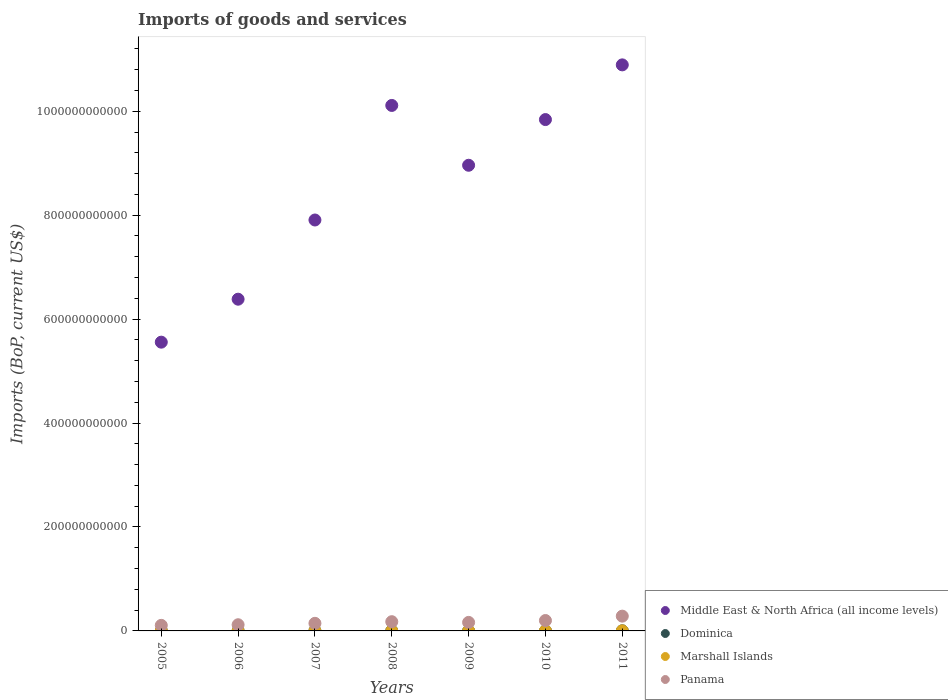How many different coloured dotlines are there?
Provide a succinct answer. 4. Is the number of dotlines equal to the number of legend labels?
Offer a terse response. Yes. What is the amount spent on imports in Dominica in 2010?
Provide a succinct answer. 2.65e+08. Across all years, what is the maximum amount spent on imports in Marshall Islands?
Your answer should be very brief. 1.75e+08. Across all years, what is the minimum amount spent on imports in Middle East & North Africa (all income levels)?
Keep it short and to the point. 5.56e+11. In which year was the amount spent on imports in Marshall Islands minimum?
Offer a very short reply. 2006. What is the total amount spent on imports in Dominica in the graph?
Your response must be concise. 1.71e+09. What is the difference between the amount spent on imports in Marshall Islands in 2005 and that in 2011?
Provide a succinct answer. -4.01e+07. What is the difference between the amount spent on imports in Middle East & North Africa (all income levels) in 2008 and the amount spent on imports in Dominica in 2009?
Offer a terse response. 1.01e+12. What is the average amount spent on imports in Dominica per year?
Keep it short and to the point. 2.45e+08. In the year 2005, what is the difference between the amount spent on imports in Middle East & North Africa (all income levels) and amount spent on imports in Marshall Islands?
Keep it short and to the point. 5.56e+11. In how many years, is the amount spent on imports in Panama greater than 160000000000 US$?
Offer a terse response. 0. What is the ratio of the amount spent on imports in Dominica in 2009 to that in 2010?
Provide a short and direct response. 1. What is the difference between the highest and the second highest amount spent on imports in Marshall Islands?
Provide a succinct answer. 1.13e+07. What is the difference between the highest and the lowest amount spent on imports in Dominica?
Ensure brevity in your answer.  9.12e+07. In how many years, is the amount spent on imports in Panama greater than the average amount spent on imports in Panama taken over all years?
Offer a very short reply. 3. Is the sum of the amount spent on imports in Marshall Islands in 2010 and 2011 greater than the maximum amount spent on imports in Panama across all years?
Your answer should be compact. No. Is it the case that in every year, the sum of the amount spent on imports in Marshall Islands and amount spent on imports in Dominica  is greater than the sum of amount spent on imports in Middle East & North Africa (all income levels) and amount spent on imports in Panama?
Your answer should be very brief. Yes. Is it the case that in every year, the sum of the amount spent on imports in Marshall Islands and amount spent on imports in Panama  is greater than the amount spent on imports in Middle East & North Africa (all income levels)?
Provide a succinct answer. No. Does the amount spent on imports in Panama monotonically increase over the years?
Your answer should be compact. No. Is the amount spent on imports in Dominica strictly greater than the amount spent on imports in Panama over the years?
Your response must be concise. No. How many years are there in the graph?
Keep it short and to the point. 7. What is the difference between two consecutive major ticks on the Y-axis?
Offer a terse response. 2.00e+11. How many legend labels are there?
Your response must be concise. 4. What is the title of the graph?
Your response must be concise. Imports of goods and services. What is the label or title of the Y-axis?
Keep it short and to the point. Imports (BoP, current US$). What is the Imports (BoP, current US$) of Middle East & North Africa (all income levels) in 2005?
Your answer should be very brief. 5.56e+11. What is the Imports (BoP, current US$) in Dominica in 2005?
Give a very brief answer. 1.96e+08. What is the Imports (BoP, current US$) of Marshall Islands in 2005?
Make the answer very short. 1.35e+08. What is the Imports (BoP, current US$) of Panama in 2005?
Ensure brevity in your answer.  1.07e+1. What is the Imports (BoP, current US$) of Middle East & North Africa (all income levels) in 2006?
Ensure brevity in your answer.  6.38e+11. What is the Imports (BoP, current US$) of Dominica in 2006?
Provide a short and direct response. 1.99e+08. What is the Imports (BoP, current US$) of Marshall Islands in 2006?
Your answer should be compact. 1.29e+08. What is the Imports (BoP, current US$) in Panama in 2006?
Keep it short and to the point. 1.19e+1. What is the Imports (BoP, current US$) in Middle East & North Africa (all income levels) in 2007?
Provide a succinct answer. 7.91e+11. What is the Imports (BoP, current US$) in Dominica in 2007?
Give a very brief answer. 2.36e+08. What is the Imports (BoP, current US$) of Marshall Islands in 2007?
Offer a terse response. 1.41e+08. What is the Imports (BoP, current US$) of Panama in 2007?
Provide a short and direct response. 1.46e+1. What is the Imports (BoP, current US$) of Middle East & North Africa (all income levels) in 2008?
Offer a terse response. 1.01e+12. What is the Imports (BoP, current US$) in Dominica in 2008?
Provide a short and direct response. 2.87e+08. What is the Imports (BoP, current US$) in Marshall Islands in 2008?
Ensure brevity in your answer.  1.39e+08. What is the Imports (BoP, current US$) of Panama in 2008?
Make the answer very short. 1.78e+1. What is the Imports (BoP, current US$) of Middle East & North Africa (all income levels) in 2009?
Ensure brevity in your answer.  8.96e+11. What is the Imports (BoP, current US$) of Dominica in 2009?
Provide a short and direct response. 2.64e+08. What is the Imports (BoP, current US$) in Marshall Islands in 2009?
Your response must be concise. 1.58e+08. What is the Imports (BoP, current US$) in Panama in 2009?
Make the answer very short. 1.64e+1. What is the Imports (BoP, current US$) in Middle East & North Africa (all income levels) in 2010?
Keep it short and to the point. 9.84e+11. What is the Imports (BoP, current US$) in Dominica in 2010?
Keep it short and to the point. 2.65e+08. What is the Imports (BoP, current US$) of Marshall Islands in 2010?
Your response must be concise. 1.64e+08. What is the Imports (BoP, current US$) of Panama in 2010?
Ensure brevity in your answer.  2.00e+1. What is the Imports (BoP, current US$) in Middle East & North Africa (all income levels) in 2011?
Your answer should be very brief. 1.09e+12. What is the Imports (BoP, current US$) in Dominica in 2011?
Offer a terse response. 2.65e+08. What is the Imports (BoP, current US$) in Marshall Islands in 2011?
Provide a succinct answer. 1.75e+08. What is the Imports (BoP, current US$) of Panama in 2011?
Provide a succinct answer. 2.84e+1. Across all years, what is the maximum Imports (BoP, current US$) in Middle East & North Africa (all income levels)?
Your answer should be very brief. 1.09e+12. Across all years, what is the maximum Imports (BoP, current US$) of Dominica?
Offer a very short reply. 2.87e+08. Across all years, what is the maximum Imports (BoP, current US$) in Marshall Islands?
Provide a succinct answer. 1.75e+08. Across all years, what is the maximum Imports (BoP, current US$) in Panama?
Keep it short and to the point. 2.84e+1. Across all years, what is the minimum Imports (BoP, current US$) of Middle East & North Africa (all income levels)?
Your response must be concise. 5.56e+11. Across all years, what is the minimum Imports (BoP, current US$) of Dominica?
Offer a terse response. 1.96e+08. Across all years, what is the minimum Imports (BoP, current US$) of Marshall Islands?
Your answer should be very brief. 1.29e+08. Across all years, what is the minimum Imports (BoP, current US$) in Panama?
Ensure brevity in your answer.  1.07e+1. What is the total Imports (BoP, current US$) in Middle East & North Africa (all income levels) in the graph?
Provide a succinct answer. 5.96e+12. What is the total Imports (BoP, current US$) in Dominica in the graph?
Offer a terse response. 1.71e+09. What is the total Imports (BoP, current US$) of Marshall Islands in the graph?
Offer a terse response. 1.04e+09. What is the total Imports (BoP, current US$) in Panama in the graph?
Make the answer very short. 1.20e+11. What is the difference between the Imports (BoP, current US$) of Middle East & North Africa (all income levels) in 2005 and that in 2006?
Keep it short and to the point. -8.27e+1. What is the difference between the Imports (BoP, current US$) of Dominica in 2005 and that in 2006?
Ensure brevity in your answer.  -2.73e+06. What is the difference between the Imports (BoP, current US$) of Marshall Islands in 2005 and that in 2006?
Your answer should be very brief. 5.65e+06. What is the difference between the Imports (BoP, current US$) of Panama in 2005 and that in 2006?
Offer a very short reply. -1.18e+09. What is the difference between the Imports (BoP, current US$) of Middle East & North Africa (all income levels) in 2005 and that in 2007?
Provide a short and direct response. -2.35e+11. What is the difference between the Imports (BoP, current US$) in Dominica in 2005 and that in 2007?
Keep it short and to the point. -4.02e+07. What is the difference between the Imports (BoP, current US$) of Marshall Islands in 2005 and that in 2007?
Your answer should be very brief. -5.87e+06. What is the difference between the Imports (BoP, current US$) of Panama in 2005 and that in 2007?
Provide a short and direct response. -3.91e+09. What is the difference between the Imports (BoP, current US$) of Middle East & North Africa (all income levels) in 2005 and that in 2008?
Offer a very short reply. -4.55e+11. What is the difference between the Imports (BoP, current US$) of Dominica in 2005 and that in 2008?
Provide a succinct answer. -9.12e+07. What is the difference between the Imports (BoP, current US$) of Marshall Islands in 2005 and that in 2008?
Your answer should be compact. -4.35e+06. What is the difference between the Imports (BoP, current US$) of Panama in 2005 and that in 2008?
Give a very brief answer. -7.06e+09. What is the difference between the Imports (BoP, current US$) in Middle East & North Africa (all income levels) in 2005 and that in 2009?
Your response must be concise. -3.40e+11. What is the difference between the Imports (BoP, current US$) in Dominica in 2005 and that in 2009?
Your answer should be compact. -6.83e+07. What is the difference between the Imports (BoP, current US$) of Marshall Islands in 2005 and that in 2009?
Offer a very short reply. -2.31e+07. What is the difference between the Imports (BoP, current US$) in Panama in 2005 and that in 2009?
Offer a very short reply. -5.71e+09. What is the difference between the Imports (BoP, current US$) of Middle East & North Africa (all income levels) in 2005 and that in 2010?
Ensure brevity in your answer.  -4.28e+11. What is the difference between the Imports (BoP, current US$) in Dominica in 2005 and that in 2010?
Your answer should be compact. -6.84e+07. What is the difference between the Imports (BoP, current US$) of Marshall Islands in 2005 and that in 2010?
Provide a succinct answer. -2.88e+07. What is the difference between the Imports (BoP, current US$) of Panama in 2005 and that in 2010?
Your answer should be compact. -9.30e+09. What is the difference between the Imports (BoP, current US$) of Middle East & North Africa (all income levels) in 2005 and that in 2011?
Provide a short and direct response. -5.34e+11. What is the difference between the Imports (BoP, current US$) in Dominica in 2005 and that in 2011?
Keep it short and to the point. -6.87e+07. What is the difference between the Imports (BoP, current US$) of Marshall Islands in 2005 and that in 2011?
Offer a terse response. -4.01e+07. What is the difference between the Imports (BoP, current US$) in Panama in 2005 and that in 2011?
Your response must be concise. -1.77e+1. What is the difference between the Imports (BoP, current US$) of Middle East & North Africa (all income levels) in 2006 and that in 2007?
Ensure brevity in your answer.  -1.52e+11. What is the difference between the Imports (BoP, current US$) in Dominica in 2006 and that in 2007?
Provide a short and direct response. -3.75e+07. What is the difference between the Imports (BoP, current US$) of Marshall Islands in 2006 and that in 2007?
Make the answer very short. -1.15e+07. What is the difference between the Imports (BoP, current US$) of Panama in 2006 and that in 2007?
Your response must be concise. -2.73e+09. What is the difference between the Imports (BoP, current US$) of Middle East & North Africa (all income levels) in 2006 and that in 2008?
Provide a succinct answer. -3.73e+11. What is the difference between the Imports (BoP, current US$) in Dominica in 2006 and that in 2008?
Keep it short and to the point. -8.85e+07. What is the difference between the Imports (BoP, current US$) of Marshall Islands in 2006 and that in 2008?
Offer a very short reply. -9.99e+06. What is the difference between the Imports (BoP, current US$) in Panama in 2006 and that in 2008?
Keep it short and to the point. -5.87e+09. What is the difference between the Imports (BoP, current US$) in Middle East & North Africa (all income levels) in 2006 and that in 2009?
Make the answer very short. -2.58e+11. What is the difference between the Imports (BoP, current US$) of Dominica in 2006 and that in 2009?
Keep it short and to the point. -6.56e+07. What is the difference between the Imports (BoP, current US$) in Marshall Islands in 2006 and that in 2009?
Offer a very short reply. -2.88e+07. What is the difference between the Imports (BoP, current US$) of Panama in 2006 and that in 2009?
Keep it short and to the point. -4.52e+09. What is the difference between the Imports (BoP, current US$) in Middle East & North Africa (all income levels) in 2006 and that in 2010?
Your answer should be compact. -3.46e+11. What is the difference between the Imports (BoP, current US$) in Dominica in 2006 and that in 2010?
Offer a very short reply. -6.57e+07. What is the difference between the Imports (BoP, current US$) of Marshall Islands in 2006 and that in 2010?
Ensure brevity in your answer.  -3.45e+07. What is the difference between the Imports (BoP, current US$) in Panama in 2006 and that in 2010?
Keep it short and to the point. -8.12e+09. What is the difference between the Imports (BoP, current US$) in Middle East & North Africa (all income levels) in 2006 and that in 2011?
Keep it short and to the point. -4.51e+11. What is the difference between the Imports (BoP, current US$) in Dominica in 2006 and that in 2011?
Offer a terse response. -6.60e+07. What is the difference between the Imports (BoP, current US$) in Marshall Islands in 2006 and that in 2011?
Provide a short and direct response. -4.58e+07. What is the difference between the Imports (BoP, current US$) of Panama in 2006 and that in 2011?
Give a very brief answer. -1.66e+1. What is the difference between the Imports (BoP, current US$) in Middle East & North Africa (all income levels) in 2007 and that in 2008?
Give a very brief answer. -2.20e+11. What is the difference between the Imports (BoP, current US$) of Dominica in 2007 and that in 2008?
Keep it short and to the point. -5.10e+07. What is the difference between the Imports (BoP, current US$) in Marshall Islands in 2007 and that in 2008?
Offer a terse response. 1.53e+06. What is the difference between the Imports (BoP, current US$) in Panama in 2007 and that in 2008?
Give a very brief answer. -3.14e+09. What is the difference between the Imports (BoP, current US$) in Middle East & North Africa (all income levels) in 2007 and that in 2009?
Ensure brevity in your answer.  -1.05e+11. What is the difference between the Imports (BoP, current US$) in Dominica in 2007 and that in 2009?
Provide a short and direct response. -2.81e+07. What is the difference between the Imports (BoP, current US$) of Marshall Islands in 2007 and that in 2009?
Your response must be concise. -1.72e+07. What is the difference between the Imports (BoP, current US$) in Panama in 2007 and that in 2009?
Offer a very short reply. -1.79e+09. What is the difference between the Imports (BoP, current US$) in Middle East & North Africa (all income levels) in 2007 and that in 2010?
Provide a succinct answer. -1.93e+11. What is the difference between the Imports (BoP, current US$) of Dominica in 2007 and that in 2010?
Ensure brevity in your answer.  -2.82e+07. What is the difference between the Imports (BoP, current US$) in Marshall Islands in 2007 and that in 2010?
Offer a very short reply. -2.30e+07. What is the difference between the Imports (BoP, current US$) in Panama in 2007 and that in 2010?
Make the answer very short. -5.39e+09. What is the difference between the Imports (BoP, current US$) of Middle East & North Africa (all income levels) in 2007 and that in 2011?
Keep it short and to the point. -2.98e+11. What is the difference between the Imports (BoP, current US$) in Dominica in 2007 and that in 2011?
Provide a short and direct response. -2.85e+07. What is the difference between the Imports (BoP, current US$) of Marshall Islands in 2007 and that in 2011?
Keep it short and to the point. -3.42e+07. What is the difference between the Imports (BoP, current US$) of Panama in 2007 and that in 2011?
Offer a terse response. -1.38e+1. What is the difference between the Imports (BoP, current US$) of Middle East & North Africa (all income levels) in 2008 and that in 2009?
Keep it short and to the point. 1.15e+11. What is the difference between the Imports (BoP, current US$) in Dominica in 2008 and that in 2009?
Provide a short and direct response. 2.29e+07. What is the difference between the Imports (BoP, current US$) of Marshall Islands in 2008 and that in 2009?
Offer a terse response. -1.88e+07. What is the difference between the Imports (BoP, current US$) in Panama in 2008 and that in 2009?
Ensure brevity in your answer.  1.35e+09. What is the difference between the Imports (BoP, current US$) in Middle East & North Africa (all income levels) in 2008 and that in 2010?
Keep it short and to the point. 2.72e+1. What is the difference between the Imports (BoP, current US$) in Dominica in 2008 and that in 2010?
Ensure brevity in your answer.  2.28e+07. What is the difference between the Imports (BoP, current US$) of Marshall Islands in 2008 and that in 2010?
Offer a very short reply. -2.45e+07. What is the difference between the Imports (BoP, current US$) in Panama in 2008 and that in 2010?
Your response must be concise. -2.24e+09. What is the difference between the Imports (BoP, current US$) of Middle East & North Africa (all income levels) in 2008 and that in 2011?
Your response must be concise. -7.81e+1. What is the difference between the Imports (BoP, current US$) in Dominica in 2008 and that in 2011?
Your answer should be compact. 2.25e+07. What is the difference between the Imports (BoP, current US$) of Marshall Islands in 2008 and that in 2011?
Offer a terse response. -3.58e+07. What is the difference between the Imports (BoP, current US$) of Panama in 2008 and that in 2011?
Your answer should be very brief. -1.07e+1. What is the difference between the Imports (BoP, current US$) of Middle East & North Africa (all income levels) in 2009 and that in 2010?
Keep it short and to the point. -8.79e+1. What is the difference between the Imports (BoP, current US$) of Dominica in 2009 and that in 2010?
Ensure brevity in your answer.  -5.28e+04. What is the difference between the Imports (BoP, current US$) in Marshall Islands in 2009 and that in 2010?
Keep it short and to the point. -5.73e+06. What is the difference between the Imports (BoP, current US$) of Panama in 2009 and that in 2010?
Offer a terse response. -3.59e+09. What is the difference between the Imports (BoP, current US$) of Middle East & North Africa (all income levels) in 2009 and that in 2011?
Your response must be concise. -1.93e+11. What is the difference between the Imports (BoP, current US$) in Dominica in 2009 and that in 2011?
Give a very brief answer. -3.41e+05. What is the difference between the Imports (BoP, current US$) in Marshall Islands in 2009 and that in 2011?
Give a very brief answer. -1.70e+07. What is the difference between the Imports (BoP, current US$) in Panama in 2009 and that in 2011?
Offer a terse response. -1.20e+1. What is the difference between the Imports (BoP, current US$) of Middle East & North Africa (all income levels) in 2010 and that in 2011?
Give a very brief answer. -1.05e+11. What is the difference between the Imports (BoP, current US$) of Dominica in 2010 and that in 2011?
Offer a terse response. -2.88e+05. What is the difference between the Imports (BoP, current US$) in Marshall Islands in 2010 and that in 2011?
Offer a very short reply. -1.13e+07. What is the difference between the Imports (BoP, current US$) of Panama in 2010 and that in 2011?
Offer a very short reply. -8.44e+09. What is the difference between the Imports (BoP, current US$) of Middle East & North Africa (all income levels) in 2005 and the Imports (BoP, current US$) of Dominica in 2006?
Make the answer very short. 5.55e+11. What is the difference between the Imports (BoP, current US$) in Middle East & North Africa (all income levels) in 2005 and the Imports (BoP, current US$) in Marshall Islands in 2006?
Your response must be concise. 5.56e+11. What is the difference between the Imports (BoP, current US$) in Middle East & North Africa (all income levels) in 2005 and the Imports (BoP, current US$) in Panama in 2006?
Provide a succinct answer. 5.44e+11. What is the difference between the Imports (BoP, current US$) in Dominica in 2005 and the Imports (BoP, current US$) in Marshall Islands in 2006?
Offer a very short reply. 6.69e+07. What is the difference between the Imports (BoP, current US$) of Dominica in 2005 and the Imports (BoP, current US$) of Panama in 2006?
Offer a very short reply. -1.17e+1. What is the difference between the Imports (BoP, current US$) of Marshall Islands in 2005 and the Imports (BoP, current US$) of Panama in 2006?
Your answer should be compact. -1.18e+1. What is the difference between the Imports (BoP, current US$) of Middle East & North Africa (all income levels) in 2005 and the Imports (BoP, current US$) of Dominica in 2007?
Provide a short and direct response. 5.55e+11. What is the difference between the Imports (BoP, current US$) of Middle East & North Africa (all income levels) in 2005 and the Imports (BoP, current US$) of Marshall Islands in 2007?
Your answer should be compact. 5.56e+11. What is the difference between the Imports (BoP, current US$) of Middle East & North Africa (all income levels) in 2005 and the Imports (BoP, current US$) of Panama in 2007?
Your answer should be compact. 5.41e+11. What is the difference between the Imports (BoP, current US$) of Dominica in 2005 and the Imports (BoP, current US$) of Marshall Islands in 2007?
Ensure brevity in your answer.  5.54e+07. What is the difference between the Imports (BoP, current US$) of Dominica in 2005 and the Imports (BoP, current US$) of Panama in 2007?
Provide a succinct answer. -1.44e+1. What is the difference between the Imports (BoP, current US$) in Marshall Islands in 2005 and the Imports (BoP, current US$) in Panama in 2007?
Offer a very short reply. -1.45e+1. What is the difference between the Imports (BoP, current US$) in Middle East & North Africa (all income levels) in 2005 and the Imports (BoP, current US$) in Dominica in 2008?
Offer a terse response. 5.55e+11. What is the difference between the Imports (BoP, current US$) in Middle East & North Africa (all income levels) in 2005 and the Imports (BoP, current US$) in Marshall Islands in 2008?
Your answer should be compact. 5.56e+11. What is the difference between the Imports (BoP, current US$) of Middle East & North Africa (all income levels) in 2005 and the Imports (BoP, current US$) of Panama in 2008?
Provide a short and direct response. 5.38e+11. What is the difference between the Imports (BoP, current US$) of Dominica in 2005 and the Imports (BoP, current US$) of Marshall Islands in 2008?
Provide a succinct answer. 5.70e+07. What is the difference between the Imports (BoP, current US$) of Dominica in 2005 and the Imports (BoP, current US$) of Panama in 2008?
Provide a short and direct response. -1.76e+1. What is the difference between the Imports (BoP, current US$) of Marshall Islands in 2005 and the Imports (BoP, current US$) of Panama in 2008?
Provide a short and direct response. -1.76e+1. What is the difference between the Imports (BoP, current US$) of Middle East & North Africa (all income levels) in 2005 and the Imports (BoP, current US$) of Dominica in 2009?
Ensure brevity in your answer.  5.55e+11. What is the difference between the Imports (BoP, current US$) in Middle East & North Africa (all income levels) in 2005 and the Imports (BoP, current US$) in Marshall Islands in 2009?
Your response must be concise. 5.55e+11. What is the difference between the Imports (BoP, current US$) of Middle East & North Africa (all income levels) in 2005 and the Imports (BoP, current US$) of Panama in 2009?
Your answer should be very brief. 5.39e+11. What is the difference between the Imports (BoP, current US$) of Dominica in 2005 and the Imports (BoP, current US$) of Marshall Islands in 2009?
Make the answer very short. 3.82e+07. What is the difference between the Imports (BoP, current US$) of Dominica in 2005 and the Imports (BoP, current US$) of Panama in 2009?
Your response must be concise. -1.62e+1. What is the difference between the Imports (BoP, current US$) of Marshall Islands in 2005 and the Imports (BoP, current US$) of Panama in 2009?
Provide a succinct answer. -1.63e+1. What is the difference between the Imports (BoP, current US$) of Middle East & North Africa (all income levels) in 2005 and the Imports (BoP, current US$) of Dominica in 2010?
Your answer should be compact. 5.55e+11. What is the difference between the Imports (BoP, current US$) of Middle East & North Africa (all income levels) in 2005 and the Imports (BoP, current US$) of Marshall Islands in 2010?
Make the answer very short. 5.55e+11. What is the difference between the Imports (BoP, current US$) of Middle East & North Africa (all income levels) in 2005 and the Imports (BoP, current US$) of Panama in 2010?
Your answer should be very brief. 5.36e+11. What is the difference between the Imports (BoP, current US$) of Dominica in 2005 and the Imports (BoP, current US$) of Marshall Islands in 2010?
Give a very brief answer. 3.25e+07. What is the difference between the Imports (BoP, current US$) of Dominica in 2005 and the Imports (BoP, current US$) of Panama in 2010?
Provide a short and direct response. -1.98e+1. What is the difference between the Imports (BoP, current US$) of Marshall Islands in 2005 and the Imports (BoP, current US$) of Panama in 2010?
Provide a succinct answer. -1.99e+1. What is the difference between the Imports (BoP, current US$) in Middle East & North Africa (all income levels) in 2005 and the Imports (BoP, current US$) in Dominica in 2011?
Provide a succinct answer. 5.55e+11. What is the difference between the Imports (BoP, current US$) of Middle East & North Africa (all income levels) in 2005 and the Imports (BoP, current US$) of Marshall Islands in 2011?
Your answer should be compact. 5.55e+11. What is the difference between the Imports (BoP, current US$) in Middle East & North Africa (all income levels) in 2005 and the Imports (BoP, current US$) in Panama in 2011?
Your answer should be compact. 5.27e+11. What is the difference between the Imports (BoP, current US$) of Dominica in 2005 and the Imports (BoP, current US$) of Marshall Islands in 2011?
Your response must be concise. 2.12e+07. What is the difference between the Imports (BoP, current US$) in Dominica in 2005 and the Imports (BoP, current US$) in Panama in 2011?
Give a very brief answer. -2.82e+1. What is the difference between the Imports (BoP, current US$) of Marshall Islands in 2005 and the Imports (BoP, current US$) of Panama in 2011?
Your response must be concise. -2.83e+1. What is the difference between the Imports (BoP, current US$) in Middle East & North Africa (all income levels) in 2006 and the Imports (BoP, current US$) in Dominica in 2007?
Your answer should be very brief. 6.38e+11. What is the difference between the Imports (BoP, current US$) of Middle East & North Africa (all income levels) in 2006 and the Imports (BoP, current US$) of Marshall Islands in 2007?
Your answer should be compact. 6.38e+11. What is the difference between the Imports (BoP, current US$) in Middle East & North Africa (all income levels) in 2006 and the Imports (BoP, current US$) in Panama in 2007?
Offer a very short reply. 6.24e+11. What is the difference between the Imports (BoP, current US$) of Dominica in 2006 and the Imports (BoP, current US$) of Marshall Islands in 2007?
Your response must be concise. 5.82e+07. What is the difference between the Imports (BoP, current US$) of Dominica in 2006 and the Imports (BoP, current US$) of Panama in 2007?
Keep it short and to the point. -1.44e+1. What is the difference between the Imports (BoP, current US$) in Marshall Islands in 2006 and the Imports (BoP, current US$) in Panama in 2007?
Your answer should be compact. -1.45e+1. What is the difference between the Imports (BoP, current US$) of Middle East & North Africa (all income levels) in 2006 and the Imports (BoP, current US$) of Dominica in 2008?
Give a very brief answer. 6.38e+11. What is the difference between the Imports (BoP, current US$) of Middle East & North Africa (all income levels) in 2006 and the Imports (BoP, current US$) of Marshall Islands in 2008?
Keep it short and to the point. 6.38e+11. What is the difference between the Imports (BoP, current US$) of Middle East & North Africa (all income levels) in 2006 and the Imports (BoP, current US$) of Panama in 2008?
Make the answer very short. 6.21e+11. What is the difference between the Imports (BoP, current US$) of Dominica in 2006 and the Imports (BoP, current US$) of Marshall Islands in 2008?
Make the answer very short. 5.97e+07. What is the difference between the Imports (BoP, current US$) of Dominica in 2006 and the Imports (BoP, current US$) of Panama in 2008?
Your answer should be very brief. -1.76e+1. What is the difference between the Imports (BoP, current US$) in Marshall Islands in 2006 and the Imports (BoP, current US$) in Panama in 2008?
Ensure brevity in your answer.  -1.76e+1. What is the difference between the Imports (BoP, current US$) in Middle East & North Africa (all income levels) in 2006 and the Imports (BoP, current US$) in Dominica in 2009?
Your answer should be compact. 6.38e+11. What is the difference between the Imports (BoP, current US$) of Middle East & North Africa (all income levels) in 2006 and the Imports (BoP, current US$) of Marshall Islands in 2009?
Give a very brief answer. 6.38e+11. What is the difference between the Imports (BoP, current US$) of Middle East & North Africa (all income levels) in 2006 and the Imports (BoP, current US$) of Panama in 2009?
Your response must be concise. 6.22e+11. What is the difference between the Imports (BoP, current US$) in Dominica in 2006 and the Imports (BoP, current US$) in Marshall Islands in 2009?
Offer a terse response. 4.09e+07. What is the difference between the Imports (BoP, current US$) in Dominica in 2006 and the Imports (BoP, current US$) in Panama in 2009?
Make the answer very short. -1.62e+1. What is the difference between the Imports (BoP, current US$) of Marshall Islands in 2006 and the Imports (BoP, current US$) of Panama in 2009?
Provide a short and direct response. -1.63e+1. What is the difference between the Imports (BoP, current US$) in Middle East & North Africa (all income levels) in 2006 and the Imports (BoP, current US$) in Dominica in 2010?
Make the answer very short. 6.38e+11. What is the difference between the Imports (BoP, current US$) in Middle East & North Africa (all income levels) in 2006 and the Imports (BoP, current US$) in Marshall Islands in 2010?
Your answer should be very brief. 6.38e+11. What is the difference between the Imports (BoP, current US$) in Middle East & North Africa (all income levels) in 2006 and the Imports (BoP, current US$) in Panama in 2010?
Make the answer very short. 6.18e+11. What is the difference between the Imports (BoP, current US$) of Dominica in 2006 and the Imports (BoP, current US$) of Marshall Islands in 2010?
Provide a succinct answer. 3.52e+07. What is the difference between the Imports (BoP, current US$) in Dominica in 2006 and the Imports (BoP, current US$) in Panama in 2010?
Offer a terse response. -1.98e+1. What is the difference between the Imports (BoP, current US$) of Marshall Islands in 2006 and the Imports (BoP, current US$) of Panama in 2010?
Make the answer very short. -1.99e+1. What is the difference between the Imports (BoP, current US$) in Middle East & North Africa (all income levels) in 2006 and the Imports (BoP, current US$) in Dominica in 2011?
Ensure brevity in your answer.  6.38e+11. What is the difference between the Imports (BoP, current US$) in Middle East & North Africa (all income levels) in 2006 and the Imports (BoP, current US$) in Marshall Islands in 2011?
Keep it short and to the point. 6.38e+11. What is the difference between the Imports (BoP, current US$) in Middle East & North Africa (all income levels) in 2006 and the Imports (BoP, current US$) in Panama in 2011?
Provide a succinct answer. 6.10e+11. What is the difference between the Imports (BoP, current US$) in Dominica in 2006 and the Imports (BoP, current US$) in Marshall Islands in 2011?
Provide a short and direct response. 2.39e+07. What is the difference between the Imports (BoP, current US$) in Dominica in 2006 and the Imports (BoP, current US$) in Panama in 2011?
Provide a succinct answer. -2.82e+1. What is the difference between the Imports (BoP, current US$) of Marshall Islands in 2006 and the Imports (BoP, current US$) of Panama in 2011?
Keep it short and to the point. -2.83e+1. What is the difference between the Imports (BoP, current US$) of Middle East & North Africa (all income levels) in 2007 and the Imports (BoP, current US$) of Dominica in 2008?
Your response must be concise. 7.90e+11. What is the difference between the Imports (BoP, current US$) in Middle East & North Africa (all income levels) in 2007 and the Imports (BoP, current US$) in Marshall Islands in 2008?
Offer a terse response. 7.91e+11. What is the difference between the Imports (BoP, current US$) of Middle East & North Africa (all income levels) in 2007 and the Imports (BoP, current US$) of Panama in 2008?
Make the answer very short. 7.73e+11. What is the difference between the Imports (BoP, current US$) of Dominica in 2007 and the Imports (BoP, current US$) of Marshall Islands in 2008?
Provide a succinct answer. 9.72e+07. What is the difference between the Imports (BoP, current US$) in Dominica in 2007 and the Imports (BoP, current US$) in Panama in 2008?
Keep it short and to the point. -1.75e+1. What is the difference between the Imports (BoP, current US$) of Marshall Islands in 2007 and the Imports (BoP, current US$) of Panama in 2008?
Offer a very short reply. -1.76e+1. What is the difference between the Imports (BoP, current US$) in Middle East & North Africa (all income levels) in 2007 and the Imports (BoP, current US$) in Dominica in 2009?
Make the answer very short. 7.90e+11. What is the difference between the Imports (BoP, current US$) in Middle East & North Africa (all income levels) in 2007 and the Imports (BoP, current US$) in Marshall Islands in 2009?
Give a very brief answer. 7.91e+11. What is the difference between the Imports (BoP, current US$) in Middle East & North Africa (all income levels) in 2007 and the Imports (BoP, current US$) in Panama in 2009?
Your response must be concise. 7.74e+11. What is the difference between the Imports (BoP, current US$) of Dominica in 2007 and the Imports (BoP, current US$) of Marshall Islands in 2009?
Your answer should be compact. 7.84e+07. What is the difference between the Imports (BoP, current US$) in Dominica in 2007 and the Imports (BoP, current US$) in Panama in 2009?
Keep it short and to the point. -1.62e+1. What is the difference between the Imports (BoP, current US$) of Marshall Islands in 2007 and the Imports (BoP, current US$) of Panama in 2009?
Give a very brief answer. -1.63e+1. What is the difference between the Imports (BoP, current US$) of Middle East & North Africa (all income levels) in 2007 and the Imports (BoP, current US$) of Dominica in 2010?
Give a very brief answer. 7.90e+11. What is the difference between the Imports (BoP, current US$) of Middle East & North Africa (all income levels) in 2007 and the Imports (BoP, current US$) of Marshall Islands in 2010?
Ensure brevity in your answer.  7.91e+11. What is the difference between the Imports (BoP, current US$) in Middle East & North Africa (all income levels) in 2007 and the Imports (BoP, current US$) in Panama in 2010?
Keep it short and to the point. 7.71e+11. What is the difference between the Imports (BoP, current US$) in Dominica in 2007 and the Imports (BoP, current US$) in Marshall Islands in 2010?
Provide a short and direct response. 7.27e+07. What is the difference between the Imports (BoP, current US$) in Dominica in 2007 and the Imports (BoP, current US$) in Panama in 2010?
Offer a terse response. -1.98e+1. What is the difference between the Imports (BoP, current US$) of Marshall Islands in 2007 and the Imports (BoP, current US$) of Panama in 2010?
Keep it short and to the point. -1.99e+1. What is the difference between the Imports (BoP, current US$) in Middle East & North Africa (all income levels) in 2007 and the Imports (BoP, current US$) in Dominica in 2011?
Your response must be concise. 7.90e+11. What is the difference between the Imports (BoP, current US$) in Middle East & North Africa (all income levels) in 2007 and the Imports (BoP, current US$) in Marshall Islands in 2011?
Your answer should be very brief. 7.91e+11. What is the difference between the Imports (BoP, current US$) in Middle East & North Africa (all income levels) in 2007 and the Imports (BoP, current US$) in Panama in 2011?
Your answer should be very brief. 7.62e+11. What is the difference between the Imports (BoP, current US$) of Dominica in 2007 and the Imports (BoP, current US$) of Marshall Islands in 2011?
Give a very brief answer. 6.14e+07. What is the difference between the Imports (BoP, current US$) in Dominica in 2007 and the Imports (BoP, current US$) in Panama in 2011?
Ensure brevity in your answer.  -2.82e+1. What is the difference between the Imports (BoP, current US$) in Marshall Islands in 2007 and the Imports (BoP, current US$) in Panama in 2011?
Your answer should be very brief. -2.83e+1. What is the difference between the Imports (BoP, current US$) in Middle East & North Africa (all income levels) in 2008 and the Imports (BoP, current US$) in Dominica in 2009?
Provide a succinct answer. 1.01e+12. What is the difference between the Imports (BoP, current US$) in Middle East & North Africa (all income levels) in 2008 and the Imports (BoP, current US$) in Marshall Islands in 2009?
Give a very brief answer. 1.01e+12. What is the difference between the Imports (BoP, current US$) in Middle East & North Africa (all income levels) in 2008 and the Imports (BoP, current US$) in Panama in 2009?
Provide a succinct answer. 9.95e+11. What is the difference between the Imports (BoP, current US$) of Dominica in 2008 and the Imports (BoP, current US$) of Marshall Islands in 2009?
Your response must be concise. 1.29e+08. What is the difference between the Imports (BoP, current US$) in Dominica in 2008 and the Imports (BoP, current US$) in Panama in 2009?
Ensure brevity in your answer.  -1.61e+1. What is the difference between the Imports (BoP, current US$) of Marshall Islands in 2008 and the Imports (BoP, current US$) of Panama in 2009?
Keep it short and to the point. -1.63e+1. What is the difference between the Imports (BoP, current US$) in Middle East & North Africa (all income levels) in 2008 and the Imports (BoP, current US$) in Dominica in 2010?
Your answer should be very brief. 1.01e+12. What is the difference between the Imports (BoP, current US$) in Middle East & North Africa (all income levels) in 2008 and the Imports (BoP, current US$) in Marshall Islands in 2010?
Your answer should be very brief. 1.01e+12. What is the difference between the Imports (BoP, current US$) in Middle East & North Africa (all income levels) in 2008 and the Imports (BoP, current US$) in Panama in 2010?
Offer a very short reply. 9.91e+11. What is the difference between the Imports (BoP, current US$) of Dominica in 2008 and the Imports (BoP, current US$) of Marshall Islands in 2010?
Make the answer very short. 1.24e+08. What is the difference between the Imports (BoP, current US$) of Dominica in 2008 and the Imports (BoP, current US$) of Panama in 2010?
Ensure brevity in your answer.  -1.97e+1. What is the difference between the Imports (BoP, current US$) of Marshall Islands in 2008 and the Imports (BoP, current US$) of Panama in 2010?
Your response must be concise. -1.99e+1. What is the difference between the Imports (BoP, current US$) in Middle East & North Africa (all income levels) in 2008 and the Imports (BoP, current US$) in Dominica in 2011?
Your answer should be compact. 1.01e+12. What is the difference between the Imports (BoP, current US$) of Middle East & North Africa (all income levels) in 2008 and the Imports (BoP, current US$) of Marshall Islands in 2011?
Your answer should be compact. 1.01e+12. What is the difference between the Imports (BoP, current US$) in Middle East & North Africa (all income levels) in 2008 and the Imports (BoP, current US$) in Panama in 2011?
Provide a short and direct response. 9.83e+11. What is the difference between the Imports (BoP, current US$) in Dominica in 2008 and the Imports (BoP, current US$) in Marshall Islands in 2011?
Make the answer very short. 1.12e+08. What is the difference between the Imports (BoP, current US$) in Dominica in 2008 and the Imports (BoP, current US$) in Panama in 2011?
Provide a succinct answer. -2.82e+1. What is the difference between the Imports (BoP, current US$) of Marshall Islands in 2008 and the Imports (BoP, current US$) of Panama in 2011?
Make the answer very short. -2.83e+1. What is the difference between the Imports (BoP, current US$) of Middle East & North Africa (all income levels) in 2009 and the Imports (BoP, current US$) of Dominica in 2010?
Keep it short and to the point. 8.96e+11. What is the difference between the Imports (BoP, current US$) of Middle East & North Africa (all income levels) in 2009 and the Imports (BoP, current US$) of Marshall Islands in 2010?
Provide a short and direct response. 8.96e+11. What is the difference between the Imports (BoP, current US$) of Middle East & North Africa (all income levels) in 2009 and the Imports (BoP, current US$) of Panama in 2010?
Offer a very short reply. 8.76e+11. What is the difference between the Imports (BoP, current US$) in Dominica in 2009 and the Imports (BoP, current US$) in Marshall Islands in 2010?
Offer a terse response. 1.01e+08. What is the difference between the Imports (BoP, current US$) in Dominica in 2009 and the Imports (BoP, current US$) in Panama in 2010?
Offer a very short reply. -1.97e+1. What is the difference between the Imports (BoP, current US$) in Marshall Islands in 2009 and the Imports (BoP, current US$) in Panama in 2010?
Offer a very short reply. -1.98e+1. What is the difference between the Imports (BoP, current US$) in Middle East & North Africa (all income levels) in 2009 and the Imports (BoP, current US$) in Dominica in 2011?
Give a very brief answer. 8.96e+11. What is the difference between the Imports (BoP, current US$) in Middle East & North Africa (all income levels) in 2009 and the Imports (BoP, current US$) in Marshall Islands in 2011?
Provide a succinct answer. 8.96e+11. What is the difference between the Imports (BoP, current US$) of Middle East & North Africa (all income levels) in 2009 and the Imports (BoP, current US$) of Panama in 2011?
Ensure brevity in your answer.  8.68e+11. What is the difference between the Imports (BoP, current US$) of Dominica in 2009 and the Imports (BoP, current US$) of Marshall Islands in 2011?
Your answer should be compact. 8.95e+07. What is the difference between the Imports (BoP, current US$) in Dominica in 2009 and the Imports (BoP, current US$) in Panama in 2011?
Your response must be concise. -2.82e+1. What is the difference between the Imports (BoP, current US$) in Marshall Islands in 2009 and the Imports (BoP, current US$) in Panama in 2011?
Make the answer very short. -2.83e+1. What is the difference between the Imports (BoP, current US$) of Middle East & North Africa (all income levels) in 2010 and the Imports (BoP, current US$) of Dominica in 2011?
Your answer should be very brief. 9.84e+11. What is the difference between the Imports (BoP, current US$) of Middle East & North Africa (all income levels) in 2010 and the Imports (BoP, current US$) of Marshall Islands in 2011?
Your answer should be very brief. 9.84e+11. What is the difference between the Imports (BoP, current US$) in Middle East & North Africa (all income levels) in 2010 and the Imports (BoP, current US$) in Panama in 2011?
Your answer should be compact. 9.56e+11. What is the difference between the Imports (BoP, current US$) of Dominica in 2010 and the Imports (BoP, current US$) of Marshall Islands in 2011?
Provide a succinct answer. 8.96e+07. What is the difference between the Imports (BoP, current US$) of Dominica in 2010 and the Imports (BoP, current US$) of Panama in 2011?
Offer a terse response. -2.82e+1. What is the difference between the Imports (BoP, current US$) of Marshall Islands in 2010 and the Imports (BoP, current US$) of Panama in 2011?
Offer a terse response. -2.83e+1. What is the average Imports (BoP, current US$) of Middle East & North Africa (all income levels) per year?
Give a very brief answer. 8.52e+11. What is the average Imports (BoP, current US$) in Dominica per year?
Your answer should be compact. 2.45e+08. What is the average Imports (BoP, current US$) of Marshall Islands per year?
Provide a short and direct response. 1.49e+08. What is the average Imports (BoP, current US$) of Panama per year?
Offer a very short reply. 1.71e+1. In the year 2005, what is the difference between the Imports (BoP, current US$) of Middle East & North Africa (all income levels) and Imports (BoP, current US$) of Dominica?
Ensure brevity in your answer.  5.55e+11. In the year 2005, what is the difference between the Imports (BoP, current US$) in Middle East & North Africa (all income levels) and Imports (BoP, current US$) in Marshall Islands?
Ensure brevity in your answer.  5.56e+11. In the year 2005, what is the difference between the Imports (BoP, current US$) of Middle East & North Africa (all income levels) and Imports (BoP, current US$) of Panama?
Your response must be concise. 5.45e+11. In the year 2005, what is the difference between the Imports (BoP, current US$) of Dominica and Imports (BoP, current US$) of Marshall Islands?
Your answer should be compact. 6.13e+07. In the year 2005, what is the difference between the Imports (BoP, current US$) in Dominica and Imports (BoP, current US$) in Panama?
Provide a succinct answer. -1.05e+1. In the year 2005, what is the difference between the Imports (BoP, current US$) of Marshall Islands and Imports (BoP, current US$) of Panama?
Your response must be concise. -1.06e+1. In the year 2006, what is the difference between the Imports (BoP, current US$) in Middle East & North Africa (all income levels) and Imports (BoP, current US$) in Dominica?
Provide a short and direct response. 6.38e+11. In the year 2006, what is the difference between the Imports (BoP, current US$) of Middle East & North Africa (all income levels) and Imports (BoP, current US$) of Marshall Islands?
Give a very brief answer. 6.38e+11. In the year 2006, what is the difference between the Imports (BoP, current US$) in Middle East & North Africa (all income levels) and Imports (BoP, current US$) in Panama?
Make the answer very short. 6.26e+11. In the year 2006, what is the difference between the Imports (BoP, current US$) of Dominica and Imports (BoP, current US$) of Marshall Islands?
Ensure brevity in your answer.  6.97e+07. In the year 2006, what is the difference between the Imports (BoP, current US$) in Dominica and Imports (BoP, current US$) in Panama?
Offer a terse response. -1.17e+1. In the year 2006, what is the difference between the Imports (BoP, current US$) in Marshall Islands and Imports (BoP, current US$) in Panama?
Offer a terse response. -1.18e+1. In the year 2007, what is the difference between the Imports (BoP, current US$) of Middle East & North Africa (all income levels) and Imports (BoP, current US$) of Dominica?
Offer a terse response. 7.90e+11. In the year 2007, what is the difference between the Imports (BoP, current US$) in Middle East & North Africa (all income levels) and Imports (BoP, current US$) in Marshall Islands?
Ensure brevity in your answer.  7.91e+11. In the year 2007, what is the difference between the Imports (BoP, current US$) of Middle East & North Africa (all income levels) and Imports (BoP, current US$) of Panama?
Give a very brief answer. 7.76e+11. In the year 2007, what is the difference between the Imports (BoP, current US$) of Dominica and Imports (BoP, current US$) of Marshall Islands?
Keep it short and to the point. 9.56e+07. In the year 2007, what is the difference between the Imports (BoP, current US$) of Dominica and Imports (BoP, current US$) of Panama?
Offer a terse response. -1.44e+1. In the year 2007, what is the difference between the Imports (BoP, current US$) in Marshall Islands and Imports (BoP, current US$) in Panama?
Provide a short and direct response. -1.45e+1. In the year 2008, what is the difference between the Imports (BoP, current US$) in Middle East & North Africa (all income levels) and Imports (BoP, current US$) in Dominica?
Offer a very short reply. 1.01e+12. In the year 2008, what is the difference between the Imports (BoP, current US$) of Middle East & North Africa (all income levels) and Imports (BoP, current US$) of Marshall Islands?
Offer a very short reply. 1.01e+12. In the year 2008, what is the difference between the Imports (BoP, current US$) of Middle East & North Africa (all income levels) and Imports (BoP, current US$) of Panama?
Keep it short and to the point. 9.93e+11. In the year 2008, what is the difference between the Imports (BoP, current US$) of Dominica and Imports (BoP, current US$) of Marshall Islands?
Provide a short and direct response. 1.48e+08. In the year 2008, what is the difference between the Imports (BoP, current US$) of Dominica and Imports (BoP, current US$) of Panama?
Provide a short and direct response. -1.75e+1. In the year 2008, what is the difference between the Imports (BoP, current US$) in Marshall Islands and Imports (BoP, current US$) in Panama?
Provide a short and direct response. -1.76e+1. In the year 2009, what is the difference between the Imports (BoP, current US$) in Middle East & North Africa (all income levels) and Imports (BoP, current US$) in Dominica?
Offer a very short reply. 8.96e+11. In the year 2009, what is the difference between the Imports (BoP, current US$) of Middle East & North Africa (all income levels) and Imports (BoP, current US$) of Marshall Islands?
Your response must be concise. 8.96e+11. In the year 2009, what is the difference between the Imports (BoP, current US$) of Middle East & North Africa (all income levels) and Imports (BoP, current US$) of Panama?
Your answer should be compact. 8.80e+11. In the year 2009, what is the difference between the Imports (BoP, current US$) in Dominica and Imports (BoP, current US$) in Marshall Islands?
Provide a short and direct response. 1.07e+08. In the year 2009, what is the difference between the Imports (BoP, current US$) in Dominica and Imports (BoP, current US$) in Panama?
Your response must be concise. -1.61e+1. In the year 2009, what is the difference between the Imports (BoP, current US$) in Marshall Islands and Imports (BoP, current US$) in Panama?
Give a very brief answer. -1.62e+1. In the year 2010, what is the difference between the Imports (BoP, current US$) in Middle East & North Africa (all income levels) and Imports (BoP, current US$) in Dominica?
Your answer should be compact. 9.84e+11. In the year 2010, what is the difference between the Imports (BoP, current US$) of Middle East & North Africa (all income levels) and Imports (BoP, current US$) of Marshall Islands?
Make the answer very short. 9.84e+11. In the year 2010, what is the difference between the Imports (BoP, current US$) in Middle East & North Africa (all income levels) and Imports (BoP, current US$) in Panama?
Provide a succinct answer. 9.64e+11. In the year 2010, what is the difference between the Imports (BoP, current US$) of Dominica and Imports (BoP, current US$) of Marshall Islands?
Provide a short and direct response. 1.01e+08. In the year 2010, what is the difference between the Imports (BoP, current US$) of Dominica and Imports (BoP, current US$) of Panama?
Your answer should be very brief. -1.97e+1. In the year 2010, what is the difference between the Imports (BoP, current US$) in Marshall Islands and Imports (BoP, current US$) in Panama?
Offer a very short reply. -1.98e+1. In the year 2011, what is the difference between the Imports (BoP, current US$) in Middle East & North Africa (all income levels) and Imports (BoP, current US$) in Dominica?
Your answer should be compact. 1.09e+12. In the year 2011, what is the difference between the Imports (BoP, current US$) of Middle East & North Africa (all income levels) and Imports (BoP, current US$) of Marshall Islands?
Keep it short and to the point. 1.09e+12. In the year 2011, what is the difference between the Imports (BoP, current US$) of Middle East & North Africa (all income levels) and Imports (BoP, current US$) of Panama?
Offer a very short reply. 1.06e+12. In the year 2011, what is the difference between the Imports (BoP, current US$) of Dominica and Imports (BoP, current US$) of Marshall Islands?
Make the answer very short. 8.99e+07. In the year 2011, what is the difference between the Imports (BoP, current US$) of Dominica and Imports (BoP, current US$) of Panama?
Offer a terse response. -2.82e+1. In the year 2011, what is the difference between the Imports (BoP, current US$) in Marshall Islands and Imports (BoP, current US$) in Panama?
Offer a very short reply. -2.83e+1. What is the ratio of the Imports (BoP, current US$) of Middle East & North Africa (all income levels) in 2005 to that in 2006?
Provide a succinct answer. 0.87. What is the ratio of the Imports (BoP, current US$) of Dominica in 2005 to that in 2006?
Keep it short and to the point. 0.99. What is the ratio of the Imports (BoP, current US$) of Marshall Islands in 2005 to that in 2006?
Ensure brevity in your answer.  1.04. What is the ratio of the Imports (BoP, current US$) in Panama in 2005 to that in 2006?
Keep it short and to the point. 0.9. What is the ratio of the Imports (BoP, current US$) in Middle East & North Africa (all income levels) in 2005 to that in 2007?
Make the answer very short. 0.7. What is the ratio of the Imports (BoP, current US$) in Dominica in 2005 to that in 2007?
Provide a short and direct response. 0.83. What is the ratio of the Imports (BoP, current US$) of Panama in 2005 to that in 2007?
Provide a succinct answer. 0.73. What is the ratio of the Imports (BoP, current US$) of Middle East & North Africa (all income levels) in 2005 to that in 2008?
Provide a short and direct response. 0.55. What is the ratio of the Imports (BoP, current US$) in Dominica in 2005 to that in 2008?
Your answer should be very brief. 0.68. What is the ratio of the Imports (BoP, current US$) of Marshall Islands in 2005 to that in 2008?
Your answer should be very brief. 0.97. What is the ratio of the Imports (BoP, current US$) in Panama in 2005 to that in 2008?
Your answer should be compact. 0.6. What is the ratio of the Imports (BoP, current US$) of Middle East & North Africa (all income levels) in 2005 to that in 2009?
Provide a succinct answer. 0.62. What is the ratio of the Imports (BoP, current US$) in Dominica in 2005 to that in 2009?
Offer a very short reply. 0.74. What is the ratio of the Imports (BoP, current US$) of Marshall Islands in 2005 to that in 2009?
Give a very brief answer. 0.85. What is the ratio of the Imports (BoP, current US$) in Panama in 2005 to that in 2009?
Ensure brevity in your answer.  0.65. What is the ratio of the Imports (BoP, current US$) in Middle East & North Africa (all income levels) in 2005 to that in 2010?
Provide a succinct answer. 0.56. What is the ratio of the Imports (BoP, current US$) of Dominica in 2005 to that in 2010?
Provide a succinct answer. 0.74. What is the ratio of the Imports (BoP, current US$) of Marshall Islands in 2005 to that in 2010?
Offer a terse response. 0.82. What is the ratio of the Imports (BoP, current US$) in Panama in 2005 to that in 2010?
Provide a short and direct response. 0.54. What is the ratio of the Imports (BoP, current US$) in Middle East & North Africa (all income levels) in 2005 to that in 2011?
Give a very brief answer. 0.51. What is the ratio of the Imports (BoP, current US$) in Dominica in 2005 to that in 2011?
Offer a very short reply. 0.74. What is the ratio of the Imports (BoP, current US$) of Marshall Islands in 2005 to that in 2011?
Provide a short and direct response. 0.77. What is the ratio of the Imports (BoP, current US$) of Panama in 2005 to that in 2011?
Provide a short and direct response. 0.38. What is the ratio of the Imports (BoP, current US$) of Middle East & North Africa (all income levels) in 2006 to that in 2007?
Offer a very short reply. 0.81. What is the ratio of the Imports (BoP, current US$) of Dominica in 2006 to that in 2007?
Provide a succinct answer. 0.84. What is the ratio of the Imports (BoP, current US$) in Marshall Islands in 2006 to that in 2007?
Provide a succinct answer. 0.92. What is the ratio of the Imports (BoP, current US$) in Panama in 2006 to that in 2007?
Provide a succinct answer. 0.81. What is the ratio of the Imports (BoP, current US$) in Middle East & North Africa (all income levels) in 2006 to that in 2008?
Keep it short and to the point. 0.63. What is the ratio of the Imports (BoP, current US$) of Dominica in 2006 to that in 2008?
Provide a short and direct response. 0.69. What is the ratio of the Imports (BoP, current US$) of Marshall Islands in 2006 to that in 2008?
Provide a short and direct response. 0.93. What is the ratio of the Imports (BoP, current US$) in Panama in 2006 to that in 2008?
Provide a short and direct response. 0.67. What is the ratio of the Imports (BoP, current US$) of Middle East & North Africa (all income levels) in 2006 to that in 2009?
Offer a terse response. 0.71. What is the ratio of the Imports (BoP, current US$) in Dominica in 2006 to that in 2009?
Ensure brevity in your answer.  0.75. What is the ratio of the Imports (BoP, current US$) of Marshall Islands in 2006 to that in 2009?
Provide a succinct answer. 0.82. What is the ratio of the Imports (BoP, current US$) in Panama in 2006 to that in 2009?
Keep it short and to the point. 0.72. What is the ratio of the Imports (BoP, current US$) of Middle East & North Africa (all income levels) in 2006 to that in 2010?
Give a very brief answer. 0.65. What is the ratio of the Imports (BoP, current US$) of Dominica in 2006 to that in 2010?
Offer a terse response. 0.75. What is the ratio of the Imports (BoP, current US$) in Marshall Islands in 2006 to that in 2010?
Your response must be concise. 0.79. What is the ratio of the Imports (BoP, current US$) of Panama in 2006 to that in 2010?
Your answer should be very brief. 0.59. What is the ratio of the Imports (BoP, current US$) in Middle East & North Africa (all income levels) in 2006 to that in 2011?
Give a very brief answer. 0.59. What is the ratio of the Imports (BoP, current US$) in Dominica in 2006 to that in 2011?
Offer a terse response. 0.75. What is the ratio of the Imports (BoP, current US$) of Marshall Islands in 2006 to that in 2011?
Keep it short and to the point. 0.74. What is the ratio of the Imports (BoP, current US$) of Panama in 2006 to that in 2011?
Offer a terse response. 0.42. What is the ratio of the Imports (BoP, current US$) of Middle East & North Africa (all income levels) in 2007 to that in 2008?
Provide a short and direct response. 0.78. What is the ratio of the Imports (BoP, current US$) in Dominica in 2007 to that in 2008?
Ensure brevity in your answer.  0.82. What is the ratio of the Imports (BoP, current US$) of Panama in 2007 to that in 2008?
Give a very brief answer. 0.82. What is the ratio of the Imports (BoP, current US$) in Middle East & North Africa (all income levels) in 2007 to that in 2009?
Provide a short and direct response. 0.88. What is the ratio of the Imports (BoP, current US$) in Dominica in 2007 to that in 2009?
Offer a terse response. 0.89. What is the ratio of the Imports (BoP, current US$) of Marshall Islands in 2007 to that in 2009?
Make the answer very short. 0.89. What is the ratio of the Imports (BoP, current US$) in Panama in 2007 to that in 2009?
Your answer should be compact. 0.89. What is the ratio of the Imports (BoP, current US$) in Middle East & North Africa (all income levels) in 2007 to that in 2010?
Provide a short and direct response. 0.8. What is the ratio of the Imports (BoP, current US$) in Dominica in 2007 to that in 2010?
Provide a short and direct response. 0.89. What is the ratio of the Imports (BoP, current US$) in Marshall Islands in 2007 to that in 2010?
Provide a succinct answer. 0.86. What is the ratio of the Imports (BoP, current US$) in Panama in 2007 to that in 2010?
Ensure brevity in your answer.  0.73. What is the ratio of the Imports (BoP, current US$) in Middle East & North Africa (all income levels) in 2007 to that in 2011?
Your answer should be very brief. 0.73. What is the ratio of the Imports (BoP, current US$) of Dominica in 2007 to that in 2011?
Offer a terse response. 0.89. What is the ratio of the Imports (BoP, current US$) of Marshall Islands in 2007 to that in 2011?
Keep it short and to the point. 0.8. What is the ratio of the Imports (BoP, current US$) of Panama in 2007 to that in 2011?
Offer a terse response. 0.51. What is the ratio of the Imports (BoP, current US$) of Middle East & North Africa (all income levels) in 2008 to that in 2009?
Your response must be concise. 1.13. What is the ratio of the Imports (BoP, current US$) of Dominica in 2008 to that in 2009?
Provide a short and direct response. 1.09. What is the ratio of the Imports (BoP, current US$) in Marshall Islands in 2008 to that in 2009?
Provide a succinct answer. 0.88. What is the ratio of the Imports (BoP, current US$) of Panama in 2008 to that in 2009?
Give a very brief answer. 1.08. What is the ratio of the Imports (BoP, current US$) in Middle East & North Africa (all income levels) in 2008 to that in 2010?
Your answer should be compact. 1.03. What is the ratio of the Imports (BoP, current US$) in Dominica in 2008 to that in 2010?
Offer a terse response. 1.09. What is the ratio of the Imports (BoP, current US$) of Marshall Islands in 2008 to that in 2010?
Make the answer very short. 0.85. What is the ratio of the Imports (BoP, current US$) in Panama in 2008 to that in 2010?
Your response must be concise. 0.89. What is the ratio of the Imports (BoP, current US$) in Middle East & North Africa (all income levels) in 2008 to that in 2011?
Give a very brief answer. 0.93. What is the ratio of the Imports (BoP, current US$) in Dominica in 2008 to that in 2011?
Ensure brevity in your answer.  1.08. What is the ratio of the Imports (BoP, current US$) in Marshall Islands in 2008 to that in 2011?
Make the answer very short. 0.8. What is the ratio of the Imports (BoP, current US$) in Panama in 2008 to that in 2011?
Provide a short and direct response. 0.62. What is the ratio of the Imports (BoP, current US$) in Middle East & North Africa (all income levels) in 2009 to that in 2010?
Give a very brief answer. 0.91. What is the ratio of the Imports (BoP, current US$) in Dominica in 2009 to that in 2010?
Make the answer very short. 1. What is the ratio of the Imports (BoP, current US$) in Panama in 2009 to that in 2010?
Provide a succinct answer. 0.82. What is the ratio of the Imports (BoP, current US$) of Middle East & North Africa (all income levels) in 2009 to that in 2011?
Your answer should be compact. 0.82. What is the ratio of the Imports (BoP, current US$) of Dominica in 2009 to that in 2011?
Provide a short and direct response. 1. What is the ratio of the Imports (BoP, current US$) in Marshall Islands in 2009 to that in 2011?
Your response must be concise. 0.9. What is the ratio of the Imports (BoP, current US$) in Panama in 2009 to that in 2011?
Make the answer very short. 0.58. What is the ratio of the Imports (BoP, current US$) of Middle East & North Africa (all income levels) in 2010 to that in 2011?
Make the answer very short. 0.9. What is the ratio of the Imports (BoP, current US$) of Marshall Islands in 2010 to that in 2011?
Make the answer very short. 0.94. What is the ratio of the Imports (BoP, current US$) of Panama in 2010 to that in 2011?
Give a very brief answer. 0.7. What is the difference between the highest and the second highest Imports (BoP, current US$) in Middle East & North Africa (all income levels)?
Keep it short and to the point. 7.81e+1. What is the difference between the highest and the second highest Imports (BoP, current US$) of Dominica?
Ensure brevity in your answer.  2.25e+07. What is the difference between the highest and the second highest Imports (BoP, current US$) in Marshall Islands?
Provide a short and direct response. 1.13e+07. What is the difference between the highest and the second highest Imports (BoP, current US$) in Panama?
Keep it short and to the point. 8.44e+09. What is the difference between the highest and the lowest Imports (BoP, current US$) in Middle East & North Africa (all income levels)?
Your answer should be compact. 5.34e+11. What is the difference between the highest and the lowest Imports (BoP, current US$) of Dominica?
Provide a succinct answer. 9.12e+07. What is the difference between the highest and the lowest Imports (BoP, current US$) of Marshall Islands?
Your answer should be compact. 4.58e+07. What is the difference between the highest and the lowest Imports (BoP, current US$) of Panama?
Offer a very short reply. 1.77e+1. 